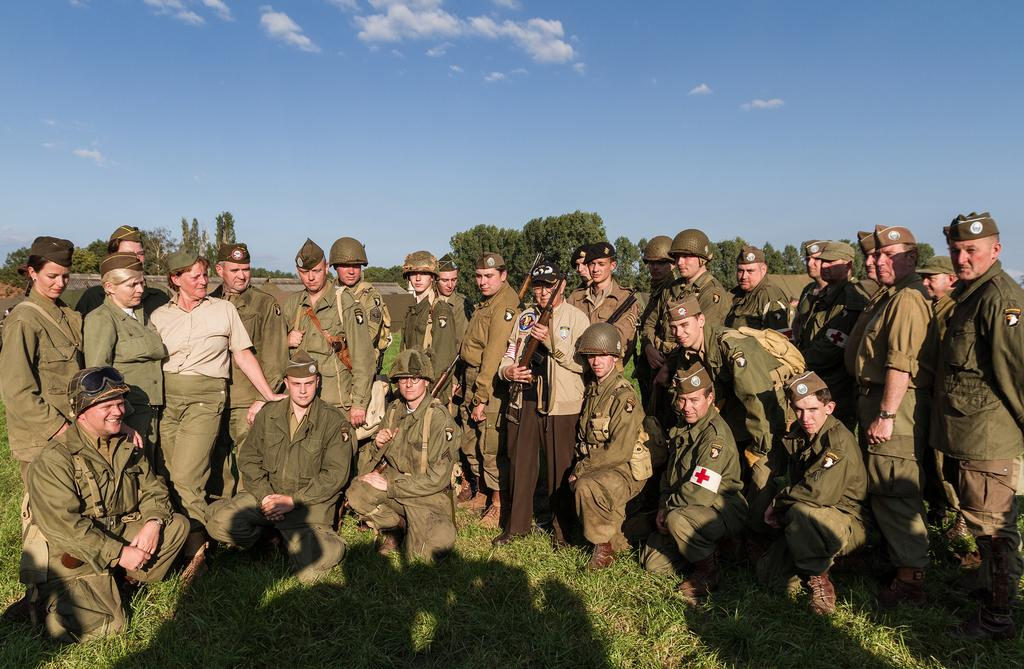How many people are in the group shown in the image? There is a group of people in the image, but the exact number is not specified. What type of headgear can be seen on some of the people in the group? Some people in the group are wearing helmets, while others are wearing caps. What can be seen in the background of the image? There are trees and clouds in the background of the image, and grass is visible as well. What type of powder is being used by the people in the image? There is no powder visible or mentioned in the image. Is there a crook present in the image? There is no crook or any indication of a crook in the image. 